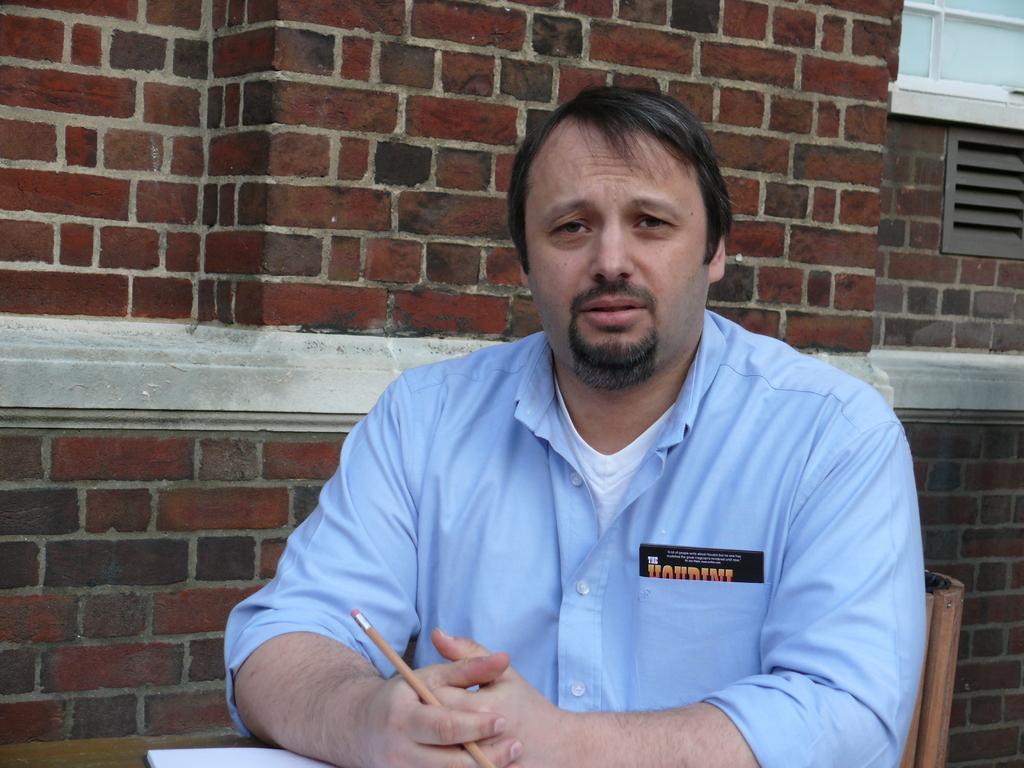Describe this image in one or two sentences. In this image in the front there is a person sitting on a chair holding a pen in his hand. In the background there is a wall which is red in colour and there is a window. In the front on the table there is a paper which is white in colour. 